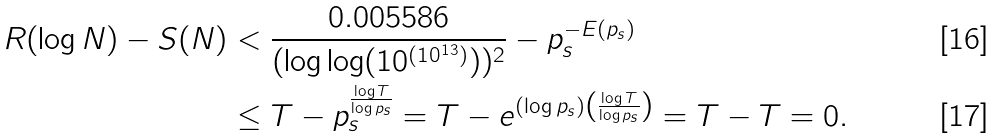<formula> <loc_0><loc_0><loc_500><loc_500>R ( \log N ) - S ( N ) & < \frac { 0 . 0 0 5 5 8 6 } { ( \log \log ( 1 0 ^ { ( 1 0 ^ { 1 3 } ) } ) ) ^ { 2 } } - p _ { s } ^ { - E ( p _ { s } ) } \\ & \leq T - p _ { s } ^ { \frac { \log T } { \log p _ { s } } } = T - e ^ { ( \log p _ { s } ) \left ( \frac { \log T } { \log p _ { s } } \right ) } = T - T = 0 .</formula> 